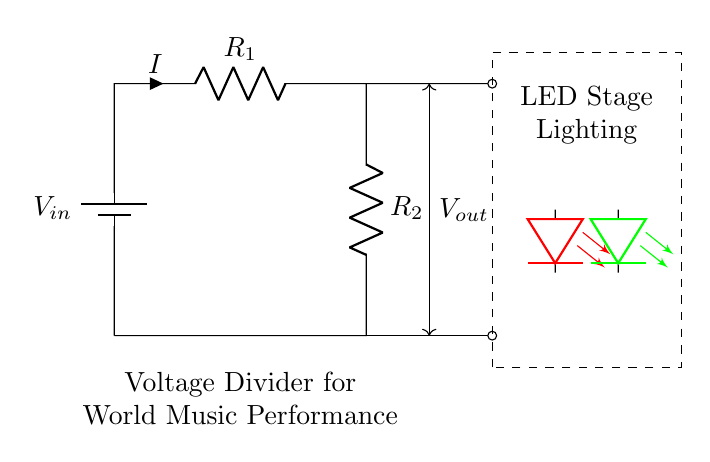What is the input voltage of the circuit? The input voltage is noted as V_in, which is the voltage provided by the battery at the top of the circuit.
Answer: V_in What do the resistors R1 and R2 do in this circuit? R1 and R2 create a voltage divider, which reduces the input voltage to a lower output voltage that can power the LEDs.
Answer: Voltage divider What colors are the LEDs used in this circuit? The circuit shows two LEDs, one red and one green, connected in parallel to the output voltage.
Answer: Red and green What is the purpose of the dashed rectangle in the circuit? The dashed rectangle indicates the section of the circuit where the LED stage lighting is powered, distinguishing it from the voltage divider itself.
Answer: LED stage lighting What is the relation of output voltage to the values of R1 and R2? According to the voltage divider rule, the output voltage (V_out) is a fraction of the input voltage, determined by the ratio of R2 to the total resistance (R1 + R2).
Answer: V_out = V_in * (R2 / (R1 + R2)) How would you increase the output voltage to the LEDs? To increase the output voltage, you could decrease the resistance of R2 or increase the resistance of R1, which changes the voltage ratio in the divider.
Answer: Decrease R2 or increase R1 